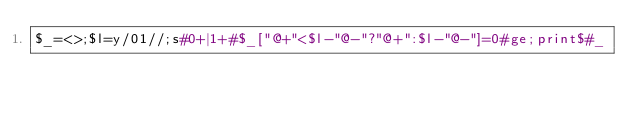<code> <loc_0><loc_0><loc_500><loc_500><_Perl_>$_=<>;$l=y/01//;s#0+|1+#$_["@+"<$l-"@-"?"@+":$l-"@-"]=0#ge;print$#_</code> 